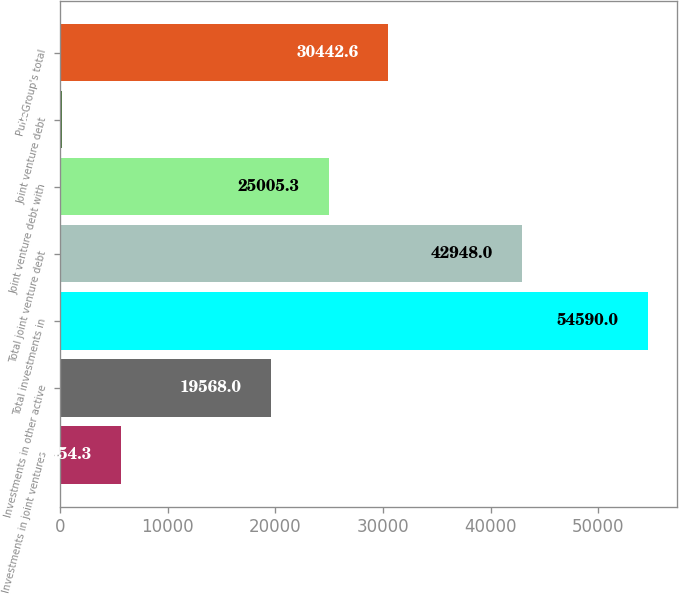Convert chart. <chart><loc_0><loc_0><loc_500><loc_500><bar_chart><fcel>Investments in joint ventures<fcel>Investments in other active<fcel>Total investments in<fcel>Total joint venture debt<fcel>Joint venture debt with<fcel>Joint venture debt<fcel>PulteGroup's total<nl><fcel>5654.3<fcel>19568<fcel>54590<fcel>42948<fcel>25005.3<fcel>217<fcel>30442.6<nl></chart> 